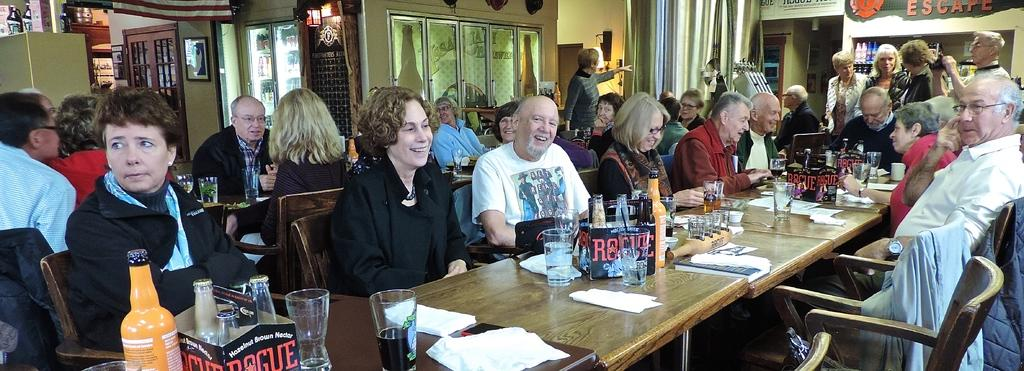What type of structure can be seen in the image? There is a wall in the image. Are there any openings in the wall? Yes, there are windows in the image. What are the people in the image doing? There are people sitting on chairs in the image. What objects can be seen on the table in the image? There are glasses, bottles, plates, and bowls on the table in the image. What type of fan is visible in the image? There is no fan present in the image. What news is being discussed by the people sitting on chairs in the image? There is no indication of any news being discussed in the image; the people are simply sitting on chairs. 